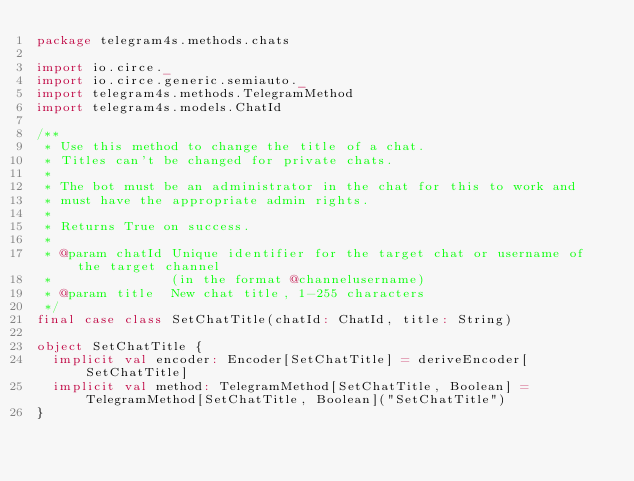Convert code to text. <code><loc_0><loc_0><loc_500><loc_500><_Scala_>package telegram4s.methods.chats

import io.circe._
import io.circe.generic.semiauto._
import telegram4s.methods.TelegramMethod
import telegram4s.models.ChatId

/**
 * Use this method to change the title of a chat.
 * Titles can't be changed for private chats.
 *
 * The bot must be an administrator in the chat for this to work and
 * must have the appropriate admin rights.
 *
 * Returns True on success.
 *
 * @param chatId Unique identifier for the target chat or username of the target channel
 *               (in the format @channelusername)
 * @param title  New chat title, 1-255 characters
 */
final case class SetChatTitle(chatId: ChatId, title: String)

object SetChatTitle {
  implicit val encoder: Encoder[SetChatTitle] = deriveEncoder[SetChatTitle]
  implicit val method: TelegramMethod[SetChatTitle, Boolean] = TelegramMethod[SetChatTitle, Boolean]("SetChatTitle")
}
</code> 